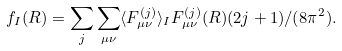Convert formula to latex. <formula><loc_0><loc_0><loc_500><loc_500>f _ { I } ( R ) = \sum _ { j } \sum _ { \mu \nu } \langle F _ { \mu \nu } ^ { ( j ) } \rangle _ { I } F _ { \mu \nu } ^ { ( j ) } ( R ) ( 2 j + 1 ) / ( 8 \pi ^ { 2 } ) .</formula> 